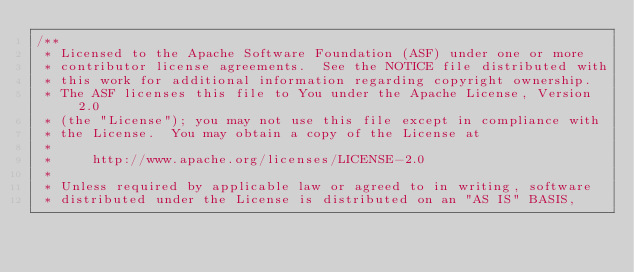<code> <loc_0><loc_0><loc_500><loc_500><_Java_>/**
 * Licensed to the Apache Software Foundation (ASF) under one or more
 * contributor license agreements.  See the NOTICE file distributed with
 * this work for additional information regarding copyright ownership.
 * The ASF licenses this file to You under the Apache License, Version 2.0
 * (the "License"); you may not use this file except in compliance with
 * the License.  You may obtain a copy of the License at
 *
 *     http://www.apache.org/licenses/LICENSE-2.0
 *
 * Unless required by applicable law or agreed to in writing, software
 * distributed under the License is distributed on an "AS IS" BASIS,</code> 